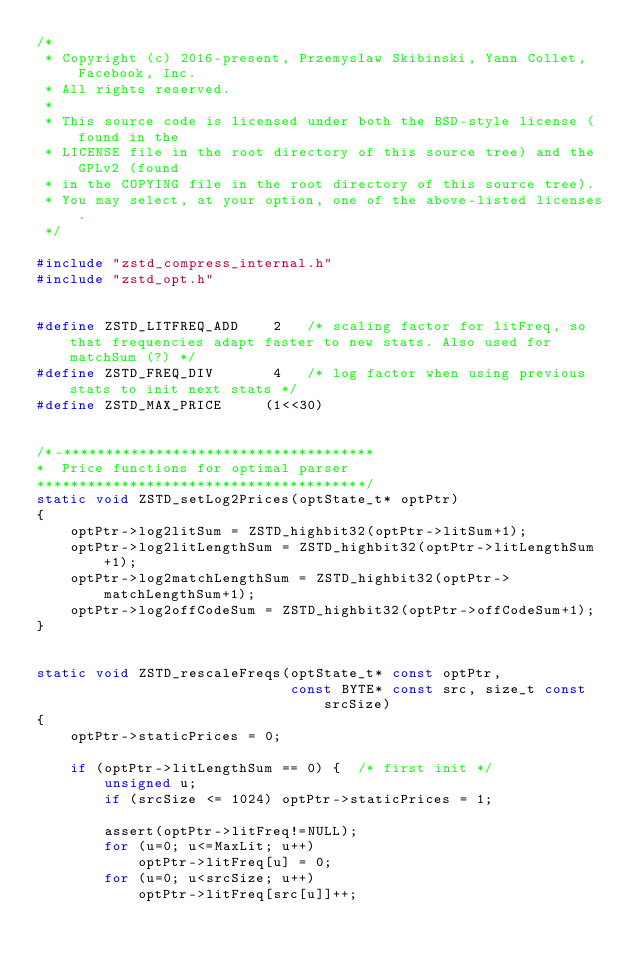Convert code to text. <code><loc_0><loc_0><loc_500><loc_500><_C_>/*
 * Copyright (c) 2016-present, Przemyslaw Skibinski, Yann Collet, Facebook, Inc.
 * All rights reserved.
 *
 * This source code is licensed under both the BSD-style license (found in the
 * LICENSE file in the root directory of this source tree) and the GPLv2 (found
 * in the COPYING file in the root directory of this source tree).
 * You may select, at your option, one of the above-listed licenses.
 */

#include "zstd_compress_internal.h"
#include "zstd_opt.h"


#define ZSTD_LITFREQ_ADD    2   /* scaling factor for litFreq, so that frequencies adapt faster to new stats. Also used for matchSum (?) */
#define ZSTD_FREQ_DIV       4   /* log factor when using previous stats to init next stats */
#define ZSTD_MAX_PRICE     (1<<30)


/*-*************************************
*  Price functions for optimal parser
***************************************/
static void ZSTD_setLog2Prices(optState_t* optPtr)
{
    optPtr->log2litSum = ZSTD_highbit32(optPtr->litSum+1);
    optPtr->log2litLengthSum = ZSTD_highbit32(optPtr->litLengthSum+1);
    optPtr->log2matchLengthSum = ZSTD_highbit32(optPtr->matchLengthSum+1);
    optPtr->log2offCodeSum = ZSTD_highbit32(optPtr->offCodeSum+1);
}


static void ZSTD_rescaleFreqs(optState_t* const optPtr,
                              const BYTE* const src, size_t const srcSize)
{
    optPtr->staticPrices = 0;

    if (optPtr->litLengthSum == 0) {  /* first init */
        unsigned u;
        if (srcSize <= 1024) optPtr->staticPrices = 1;

        assert(optPtr->litFreq!=NULL);
        for (u=0; u<=MaxLit; u++)
            optPtr->litFreq[u] = 0;
        for (u=0; u<srcSize; u++)
            optPtr->litFreq[src[u]]++;</code> 